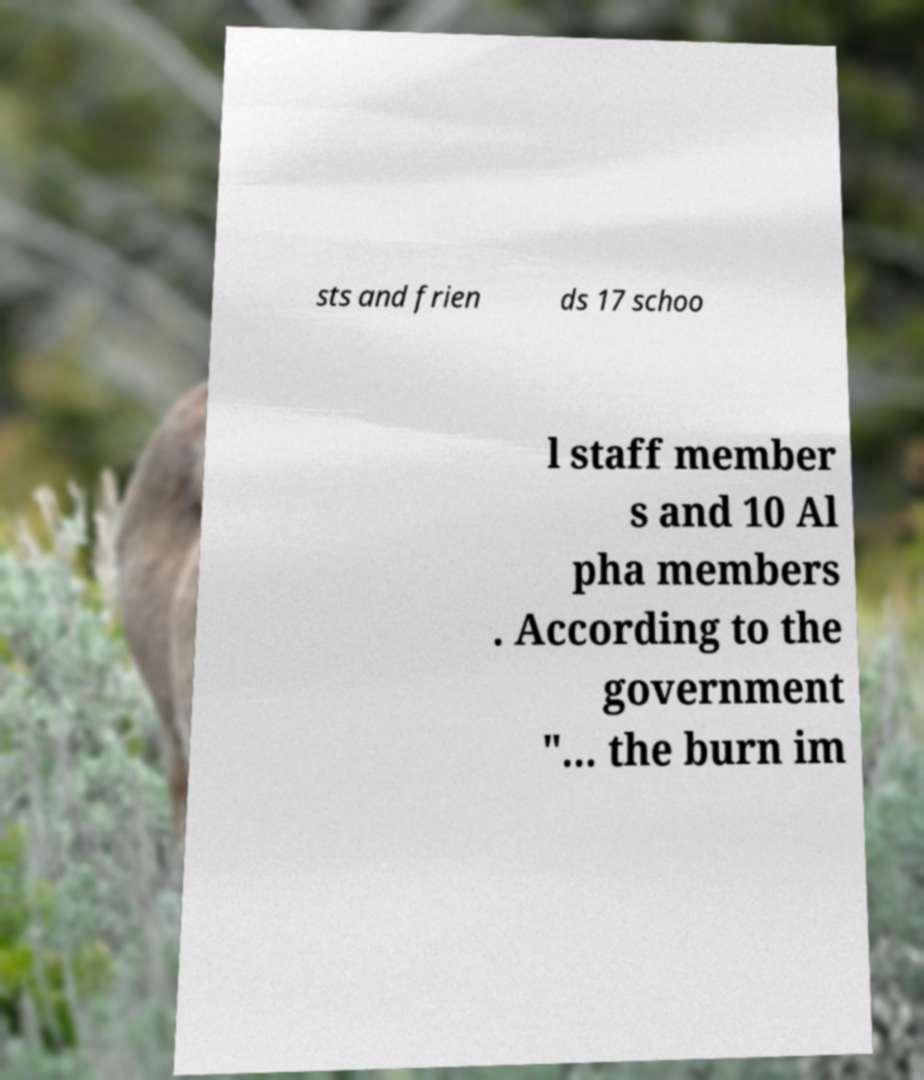Please identify and transcribe the text found in this image. sts and frien ds 17 schoo l staff member s and 10 Al pha members . According to the government "... the burn im 